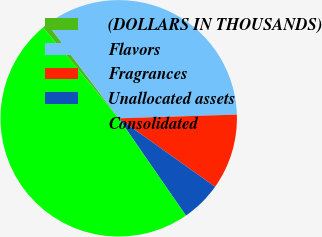Convert chart to OTSL. <chart><loc_0><loc_0><loc_500><loc_500><pie_chart><fcel>(DOLLARS IN THOUSANDS)<fcel>Flavors<fcel>Fragrances<fcel>Unallocated assets<fcel>Consolidated<nl><fcel>0.77%<fcel>34.77%<fcel>10.33%<fcel>5.55%<fcel>48.57%<nl></chart> 